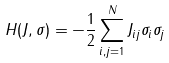<formula> <loc_0><loc_0><loc_500><loc_500>H ( J , \sigma ) = - \frac { 1 } { 2 } \sum _ { i , j = 1 } ^ { N } J _ { i j } \sigma _ { i } \sigma _ { j }</formula> 